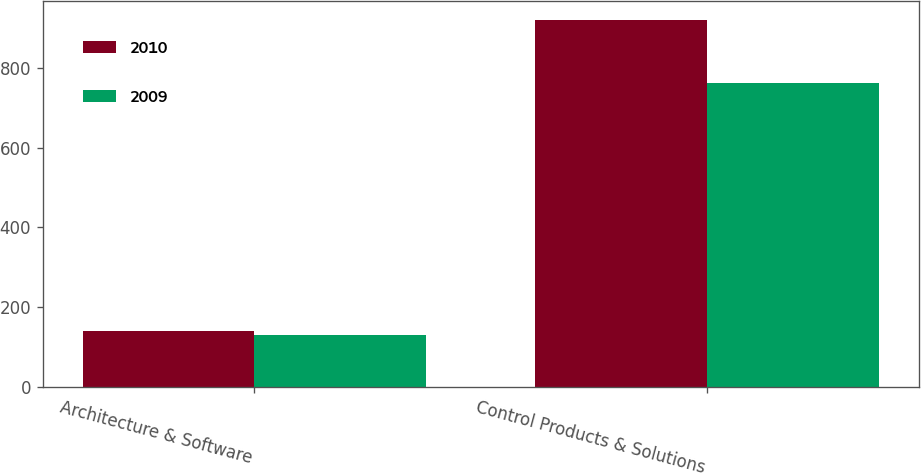Convert chart. <chart><loc_0><loc_0><loc_500><loc_500><stacked_bar_chart><ecel><fcel>Architecture & Software<fcel>Control Products & Solutions<nl><fcel>2010<fcel>140.6<fcel>921<nl><fcel>2009<fcel>130.6<fcel>761.3<nl></chart> 